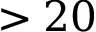Convert formula to latex. <formula><loc_0><loc_0><loc_500><loc_500>> 2 0</formula> 